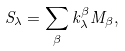Convert formula to latex. <formula><loc_0><loc_0><loc_500><loc_500>S _ { \lambda } = \sum _ { \beta } k _ { \lambda } ^ { \beta } M _ { \beta } ,</formula> 